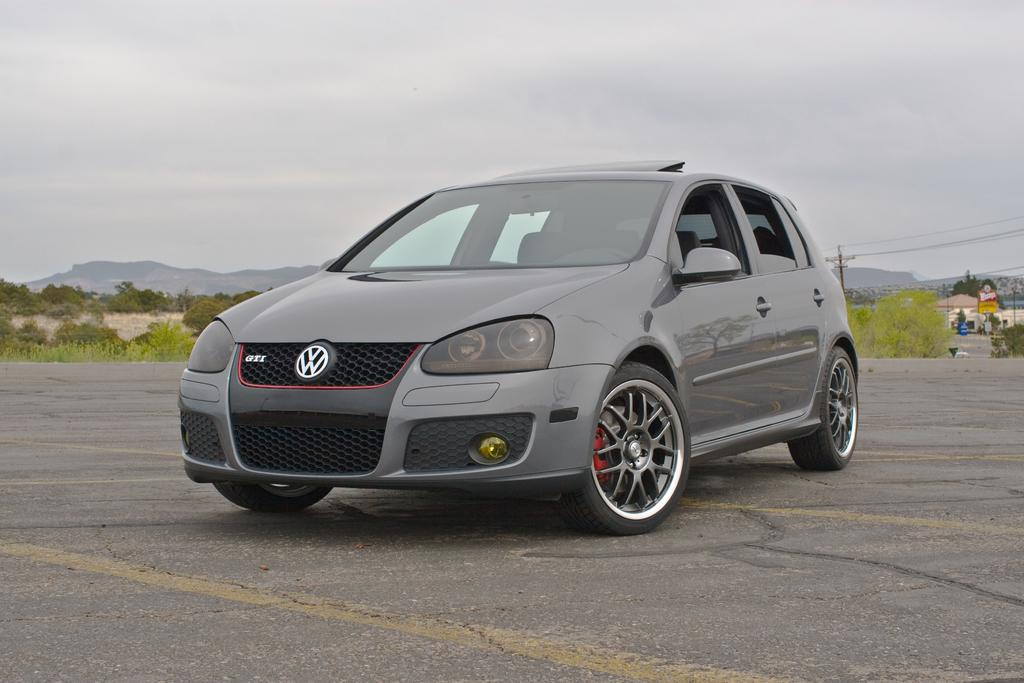What is the main subject in the center of the image? There is a car in the center of the image. What can be seen in the background of the image? Mountains, trees, poles and wires, and houses are visible in the background of the image. What is at the bottom of the image? There is a road at the bottom of the image. Can you see any astronauts kissing in space in the image? There are no astronauts or any space-related elements present in the image. 